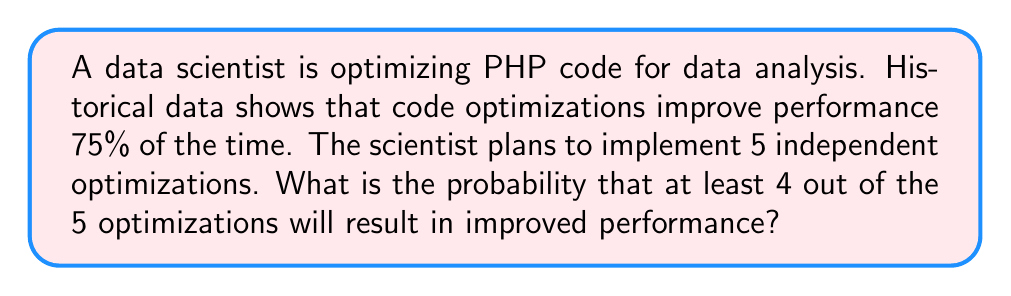Help me with this question. To solve this problem, we'll use the binomial probability distribution.

Let $p$ be the probability of success (improved performance) for a single optimization, and $n$ be the number of optimizations.

Given:
$p = 0.75$ (75% chance of improvement)
$n = 5$ (total optimizations)

We want to find the probability of at least 4 successes out of 5 trials. This is equivalent to the probability of 4 successes plus the probability of 5 successes.

The binomial probability formula is:

$$ P(X = k) = \binom{n}{k} p^k (1-p)^{n-k} $$

where $k$ is the number of successes.

For 4 successes:
$$ P(X = 4) = \binom{5}{4} (0.75)^4 (0.25)^1 $$
$$ = 5 \cdot (0.75)^4 \cdot 0.25 $$
$$ = 5 \cdot 0.31640625 \cdot 0.25 $$
$$ = 0.39550781 $$

For 5 successes:
$$ P(X = 5) = \binom{5}{5} (0.75)^5 (0.25)^0 $$
$$ = 1 \cdot (0.75)^5 $$
$$ = 0.23730469 $$

The probability of at least 4 successes is the sum of these probabilities:

$$ P(X \geq 4) = P(X = 4) + P(X = 5) $$
$$ = 0.39550781 + 0.23730469 $$
$$ = 0.63281250 $$
Answer: The probability that at least 4 out of the 5 optimizations will result in improved performance is approximately 0.6328 or 63.28%. 